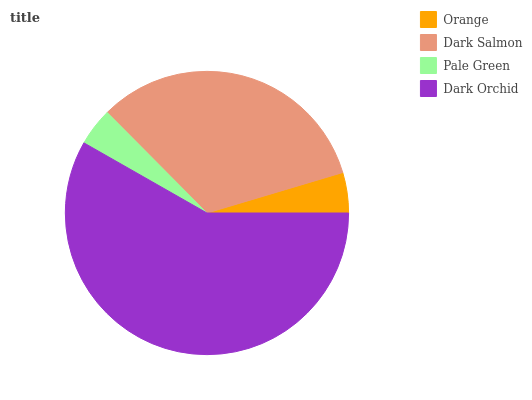Is Pale Green the minimum?
Answer yes or no. Yes. Is Dark Orchid the maximum?
Answer yes or no. Yes. Is Dark Salmon the minimum?
Answer yes or no. No. Is Dark Salmon the maximum?
Answer yes or no. No. Is Dark Salmon greater than Orange?
Answer yes or no. Yes. Is Orange less than Dark Salmon?
Answer yes or no. Yes. Is Orange greater than Dark Salmon?
Answer yes or no. No. Is Dark Salmon less than Orange?
Answer yes or no. No. Is Dark Salmon the high median?
Answer yes or no. Yes. Is Orange the low median?
Answer yes or no. Yes. Is Dark Orchid the high median?
Answer yes or no. No. Is Pale Green the low median?
Answer yes or no. No. 